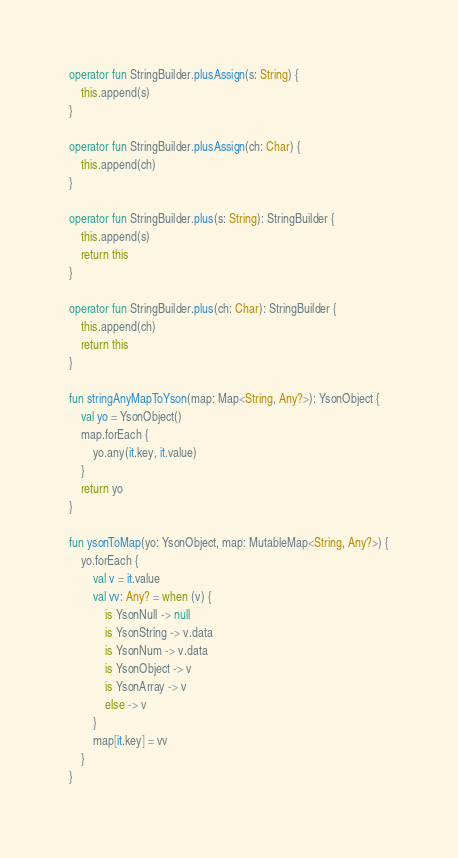<code> <loc_0><loc_0><loc_500><loc_500><_Kotlin_>
operator fun StringBuilder.plusAssign(s: String) {
	this.append(s)
}

operator fun StringBuilder.plusAssign(ch: Char) {
	this.append(ch)
}

operator fun StringBuilder.plus(s: String): StringBuilder {
	this.append(s)
	return this
}

operator fun StringBuilder.plus(ch: Char): StringBuilder {
	this.append(ch)
	return this
}

fun stringAnyMapToYson(map: Map<String, Any?>): YsonObject {
	val yo = YsonObject()
	map.forEach {
		yo.any(it.key, it.value)
	}
	return yo
}

fun ysonToMap(yo: YsonObject, map: MutableMap<String, Any?>) {
	yo.forEach {
		val v = it.value
		val vv: Any? = when (v) {
			is YsonNull -> null
			is YsonString -> v.data
			is YsonNum -> v.data
			is YsonObject -> v
			is YsonArray -> v
			else -> v
		}
		map[it.key] = vv
	}
}



</code> 